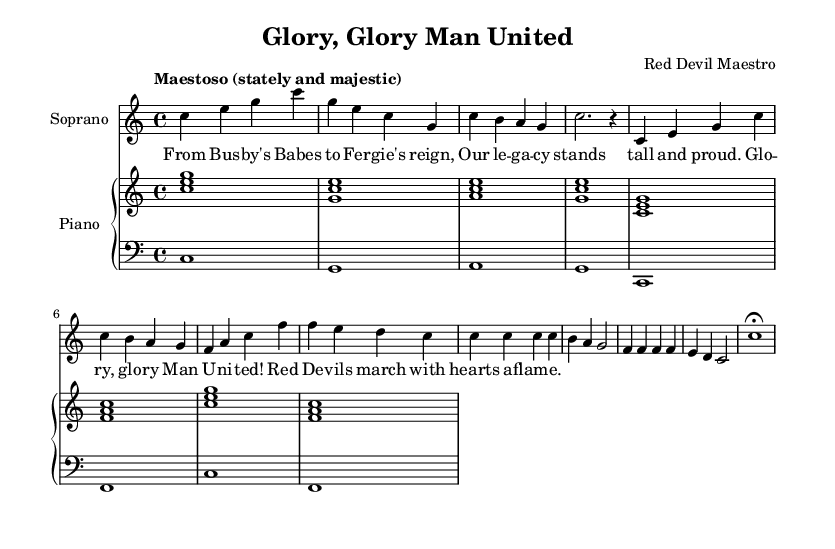What is the key signature of this music? The key signature is indicated at the beginning of the score, showing no sharps or flats, which corresponds to C major.
Answer: C major What is the time signature of the piece? The time signature is found near the beginning of the score, written as 4/4, indicating there are four beats in each measure.
Answer: 4/4 What tempo marking is provided? The tempo marking appears in the header, stating “Maestoso,” which means to play in a stately and majestic manner.
Answer: Maestoso How many measures are in the introduction? The introduction consists of four measures as indicated by the grouping of notes, which can be counted from the start of the sheet music.
Answer: 4 What is the lyrical theme of the aria? The lyrics, as visible under the soprano part, reference historical figures and victories, celebrating Manchester United's legacy.
Answer: Celebration of legacy What instrument accompanies the soprano? In the score, a piano staff is present, indicating that the piano is the accompanying instrument for the soprano.
Answer: Piano What is the final note of the soprano part? At the end of the soprano section, the note is marked as a half note (c') followed by a fermata, indicating it is sustained.
Answer: C with fermata 